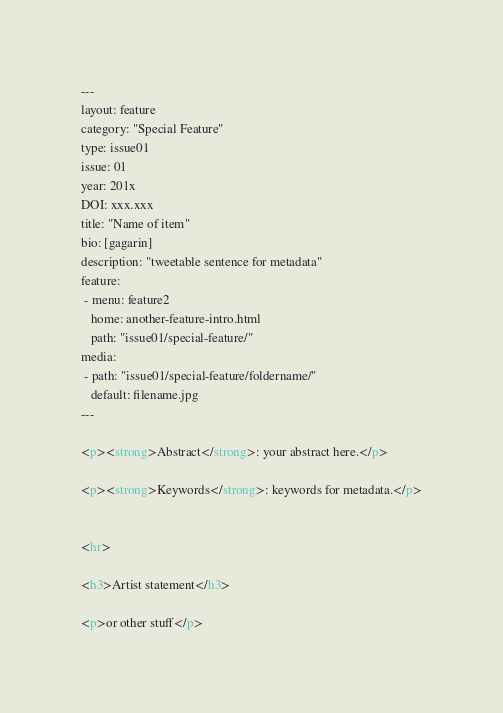Convert code to text. <code><loc_0><loc_0><loc_500><loc_500><_HTML_>---
layout: feature
category: "Special Feature"
type: issue01
issue: 01
year: 201x
DOI: xxx.xxx
title: "Name of item"
bio: [gagarin]
description: "tweetable sentence for metadata"
feature:
 - menu: feature2
   home: another-feature-intro.html
   path: "issue01/special-feature/"
media:
 - path: "issue01/special-feature/foldername/"
   default: filename.jpg
---

<p><strong>Abstract</strong>: your abstract here.</p>

<p><strong>Keywords</strong>: keywords for metadata.</p>


<hr>

<h3>Artist statement</h3>

<p>or other stuff</p> 
</code> 